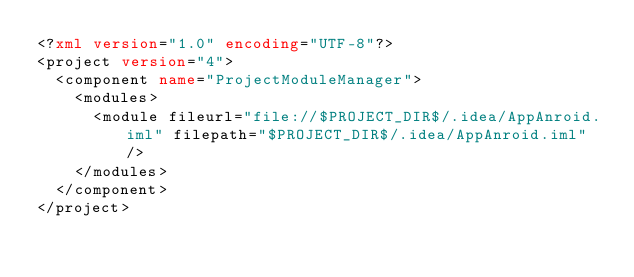Convert code to text. <code><loc_0><loc_0><loc_500><loc_500><_XML_><?xml version="1.0" encoding="UTF-8"?>
<project version="4">
  <component name="ProjectModuleManager">
    <modules>
      <module fileurl="file://$PROJECT_DIR$/.idea/AppAnroid.iml" filepath="$PROJECT_DIR$/.idea/AppAnroid.iml" />
    </modules>
  </component>
</project></code> 